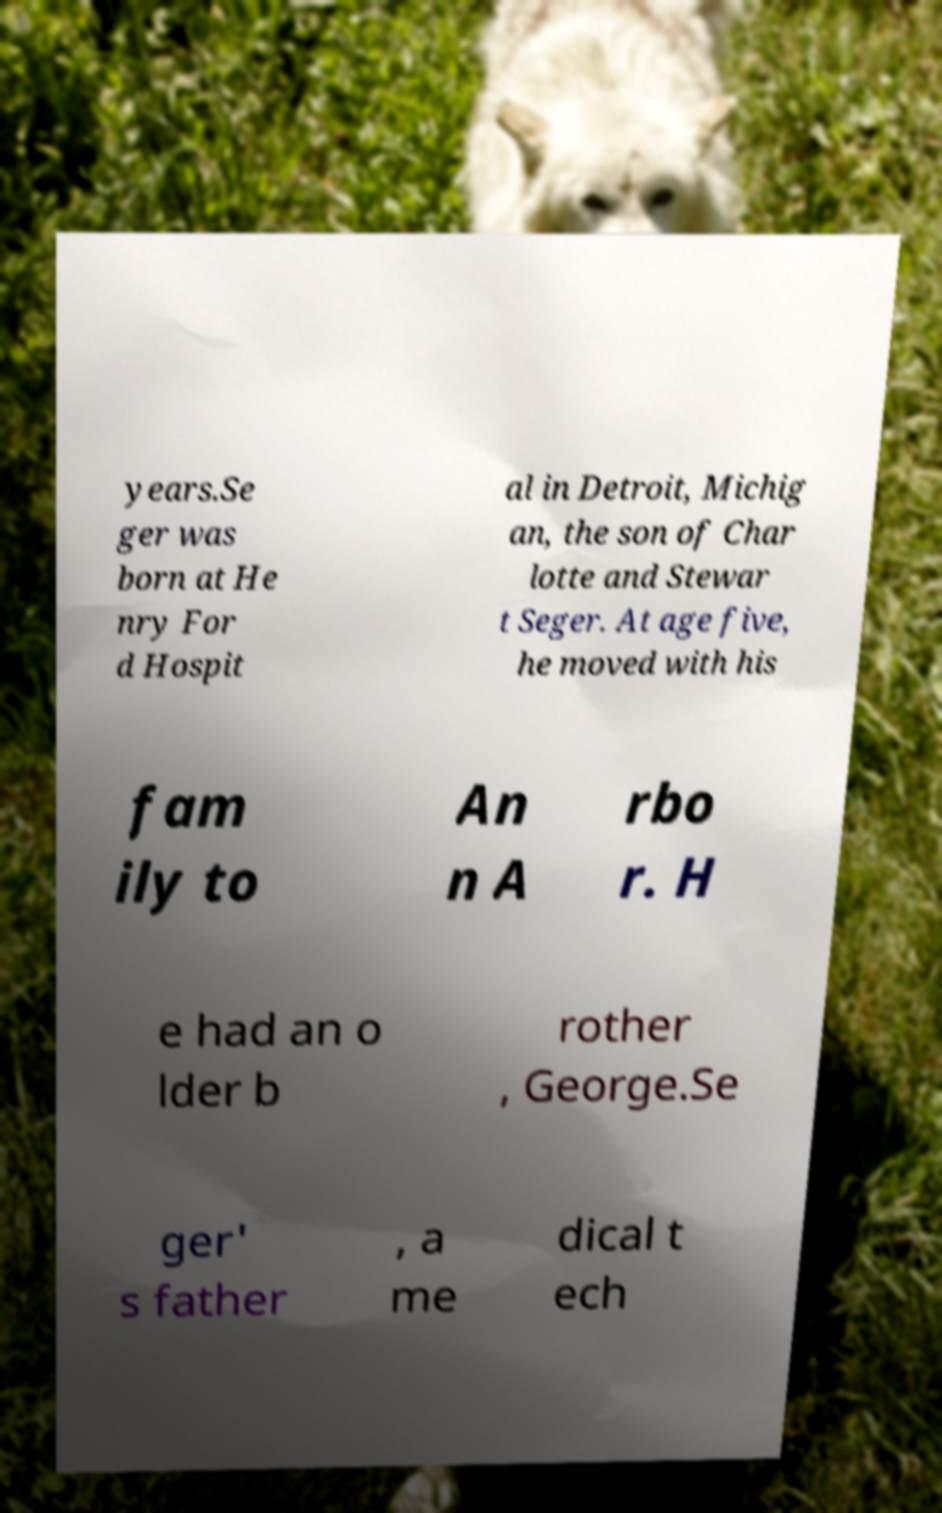For documentation purposes, I need the text within this image transcribed. Could you provide that? years.Se ger was born at He nry For d Hospit al in Detroit, Michig an, the son of Char lotte and Stewar t Seger. At age five, he moved with his fam ily to An n A rbo r. H e had an o lder b rother , George.Se ger' s father , a me dical t ech 